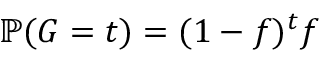Convert formula to latex. <formula><loc_0><loc_0><loc_500><loc_500>\mathbb { P } ( G = t ) = ( 1 - f ) ^ { t } f</formula> 